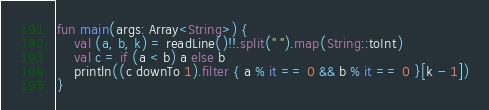Convert code to text. <code><loc_0><loc_0><loc_500><loc_500><_Kotlin_>fun main(args: Array<String>) {
    val (a, b, k) = readLine()!!.split(" ").map(String::toInt)
    val c = if (a < b) a else b
    println((c downTo 1).filter { a % it == 0 && b % it == 0 }[k - 1])
}</code> 